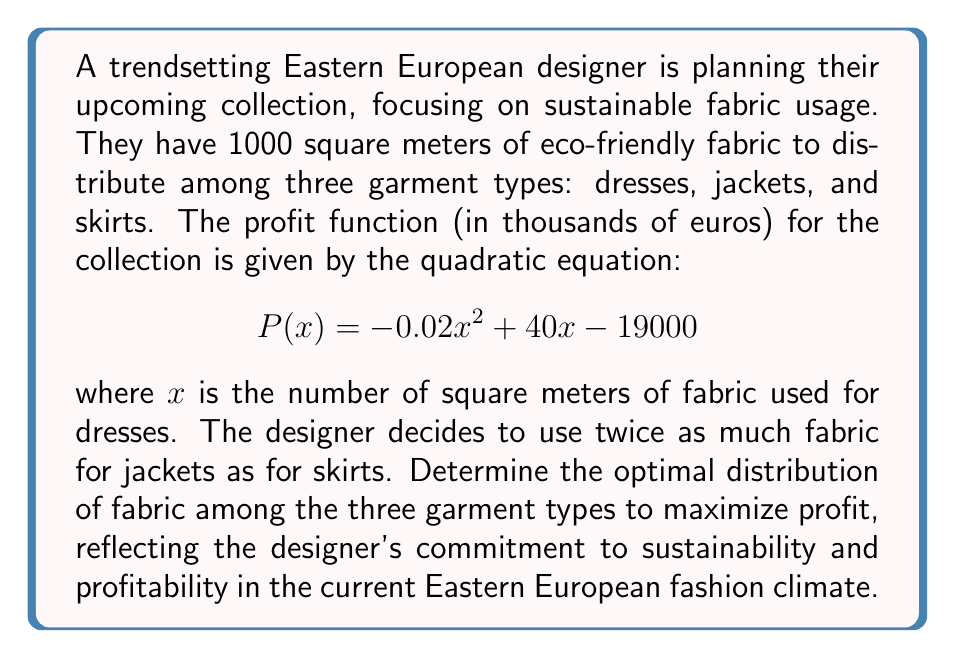Could you help me with this problem? Let's approach this step-by-step:

1) We know that the total fabric available is 1000 square meters. Let's define variables:
   $x$ = fabric for dresses
   $y$ = fabric for jackets
   $z$ = fabric for skirts

2) We're given that $y = 2z$, and the total fabric constraint is:
   $$x + y + z = 1000$$

3) Substituting $y = 2z$ into the constraint:
   $$x + 2z + z = 1000$$
   $$x + 3z = 1000$$

4) Solve for $z$:
   $$z = \frac{1000 - x}{3}$$

5) Now, we need to maximize the profit function:
   $$P(x) = -0.02x^2 + 40x - 19000$$

6) To find the maximum, we differentiate $P(x)$ and set it to zero:
   $$\frac{dP}{dx} = -0.04x + 40 = 0$$
   $$0.04x = 40$$
   $$x = 1000$$

7) This gives us the optimal amount of fabric for dresses. However, we need to check if this satisfies our constraint.

8) If $x = 1000$, then $z = \frac{1000 - 1000}{3} = 0$, which means $y = 0$ as well.

9) Since we can't have negative fabric amounts, the optimal solution must be at the boundary of our constraint.

10) Let's substitute our constraint into the profit function:
    $$P(x) = -0.02x^2 + 40x - 19000$$
    $$P(x) = -0.02x^2 + 40x - 19000$$
    $$P(1000-3z) = -0.02(1000-3z)^2 + 40(1000-3z) - 19000$$

11) Expand this:
    $$P(z) = -0.02(1000000 - 6000z + 9z^2) + 40000 - 120z - 19000$$
    $$P(z) = -20000 + 120z - 0.18z^2 + 40000 - 120z - 19000$$
    $$P(z) = -0.18z^2 + 1000$$

12) To maximize this, we differentiate and set to zero:
    $$\frac{dP}{dz} = -0.36z = 0$$
    $$z = 0$$

13) This means the optimal solution is:
    $x = 1000$ (fabric for dresses)
    $y = 0$ (fabric for jackets)
    $z = 0$ (fabric for skirts)
Answer: The optimal distribution of fabric to maximize profit is:
Dresses: 1000 square meters
Jackets: 0 square meters
Skirts: 0 square meters 